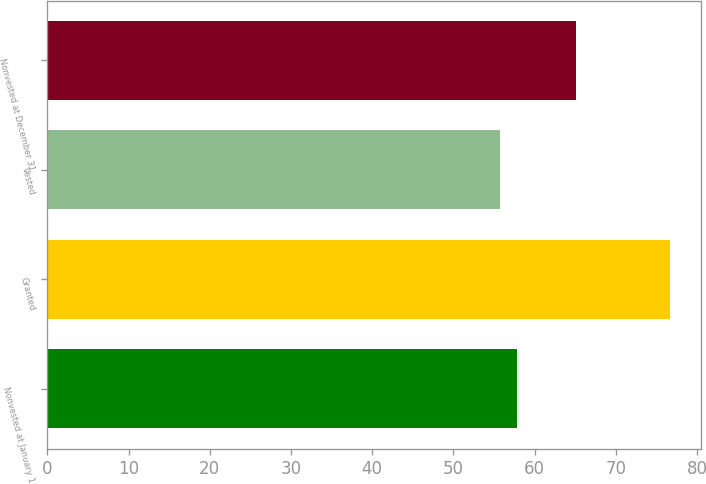Convert chart to OTSL. <chart><loc_0><loc_0><loc_500><loc_500><bar_chart><fcel>Nonvested at January 1<fcel>Granted<fcel>Vested<fcel>Nonvested at December 31<nl><fcel>57.8<fcel>76.61<fcel>55.71<fcel>65.04<nl></chart> 